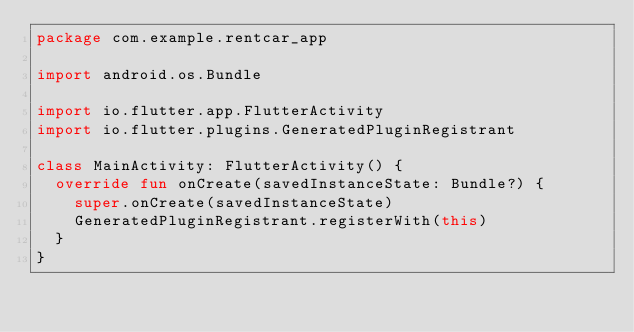<code> <loc_0><loc_0><loc_500><loc_500><_Kotlin_>package com.example.rentcar_app

import android.os.Bundle

import io.flutter.app.FlutterActivity
import io.flutter.plugins.GeneratedPluginRegistrant

class MainActivity: FlutterActivity() {
  override fun onCreate(savedInstanceState: Bundle?) {
    super.onCreate(savedInstanceState)
    GeneratedPluginRegistrant.registerWith(this)
  }
}
</code> 